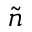<formula> <loc_0><loc_0><loc_500><loc_500>\widetilde { n }</formula> 